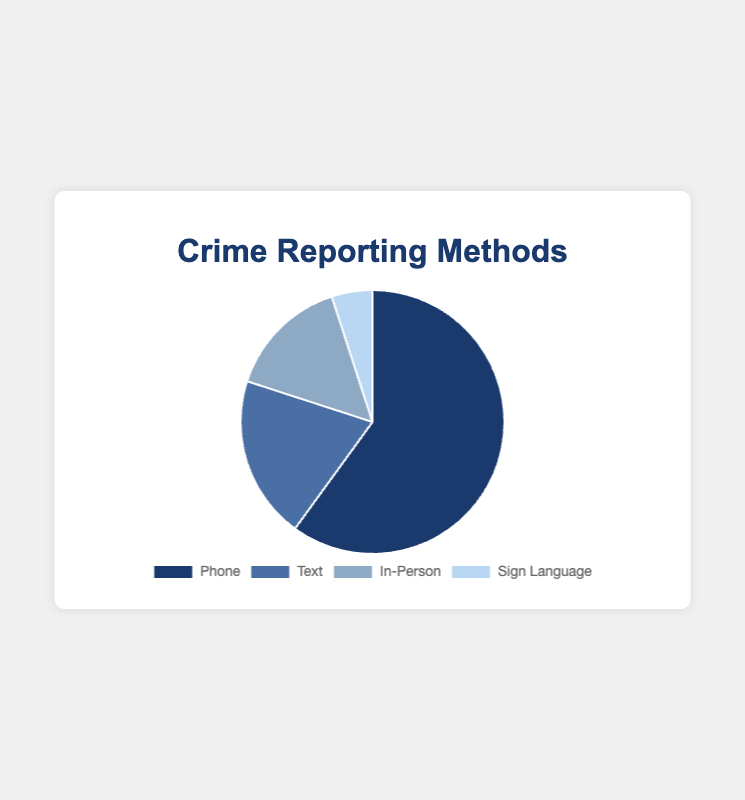Which communication method is used the most for reporting crimes? From the pie chart, the segment representing 'Phone' is the largest. This indicates that 'Phone' is the most used method.
Answer: Phone What is the proportion of crimes reported via text compared to in-person? From the pie chart, the proportion of 'Text' is 20% and 'InPerson' is 15%. Therefore, Text is reported more than InPerson by 5%.
Answer: Text is 5% more What fraction of crime reports are done either in-person or via sign language combined? The proportion of 'InPerson' is 15% and 'SignLanguage' is 5%. Adding these gives 15% + 5% = 20%.
Answer: 20% What is the total proportion of crimes reported remotely (phone and text combined)? The proportion of 'Phone' is 60% and 'Text' is 20%. Adding these gives 60% + 20% = 80%.
Answer: 80% Which method has the smallest proportion of crime reports? From the pie chart, the segment for 'SignLanguage' is the smallest.
Answer: SignLanguage Compare the visual sizes of the segments. Which two methods are almost equal in size? The segments for 'Text' and 'InPerson' are quite close to each other. Text is 20% and InPerson is 15%, which are visually similar.
Answer: Text and InPerson Is the proportion of crime reports made via phone more than half of the total reports? The proportion of 'Phone' is 60%, which is more than 50%. Therefore, more than half of the total reports are made via phone.
Answer: Yes Which two communication methods together make up one-third of the total crime reports? The proportion of 'InPerson' is 15% and 'SignLanguage' is 5%. Together they make 15% + 5% = 20%. The correct combination is 'Text' (20%) and 'SignLanguage' (5%), making 25%. Hence, none make exactly one-third (33%).
Answer: None 